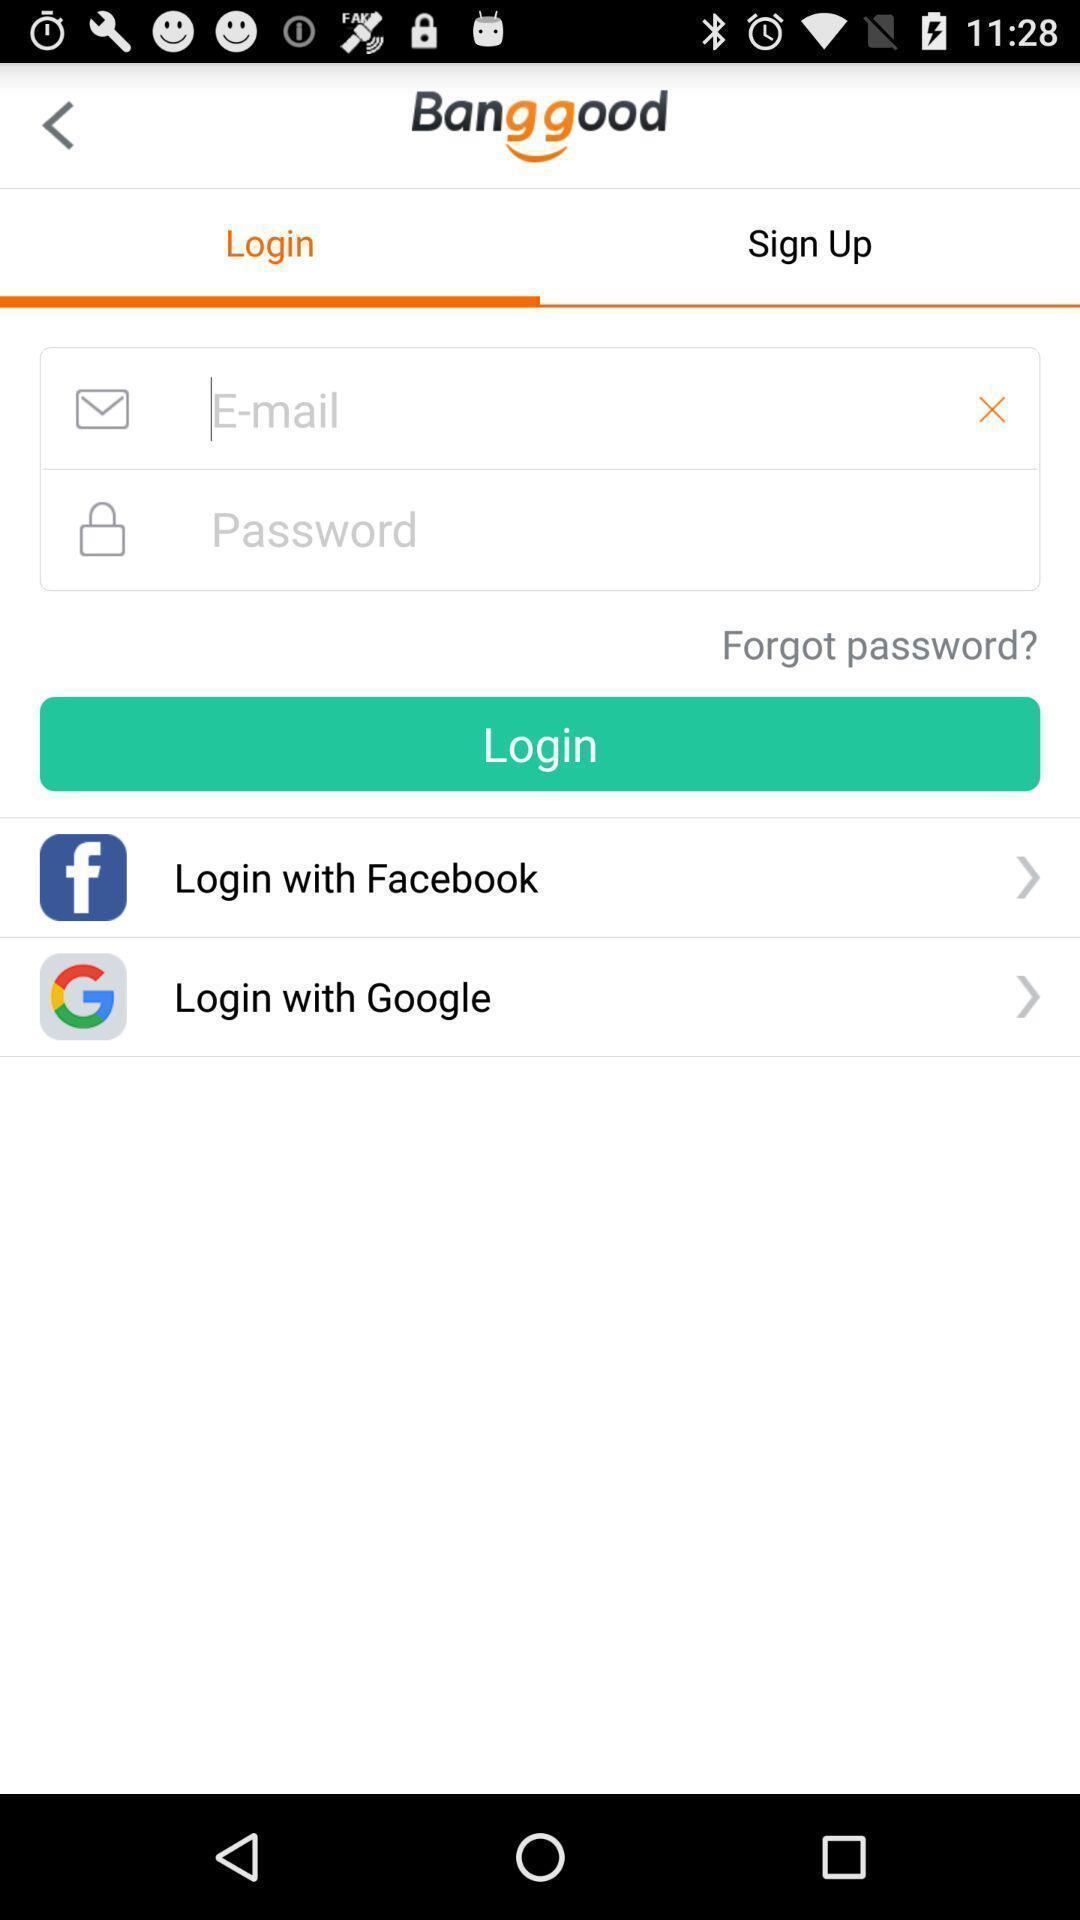Tell me what you see in this picture. Page displaying login information. 